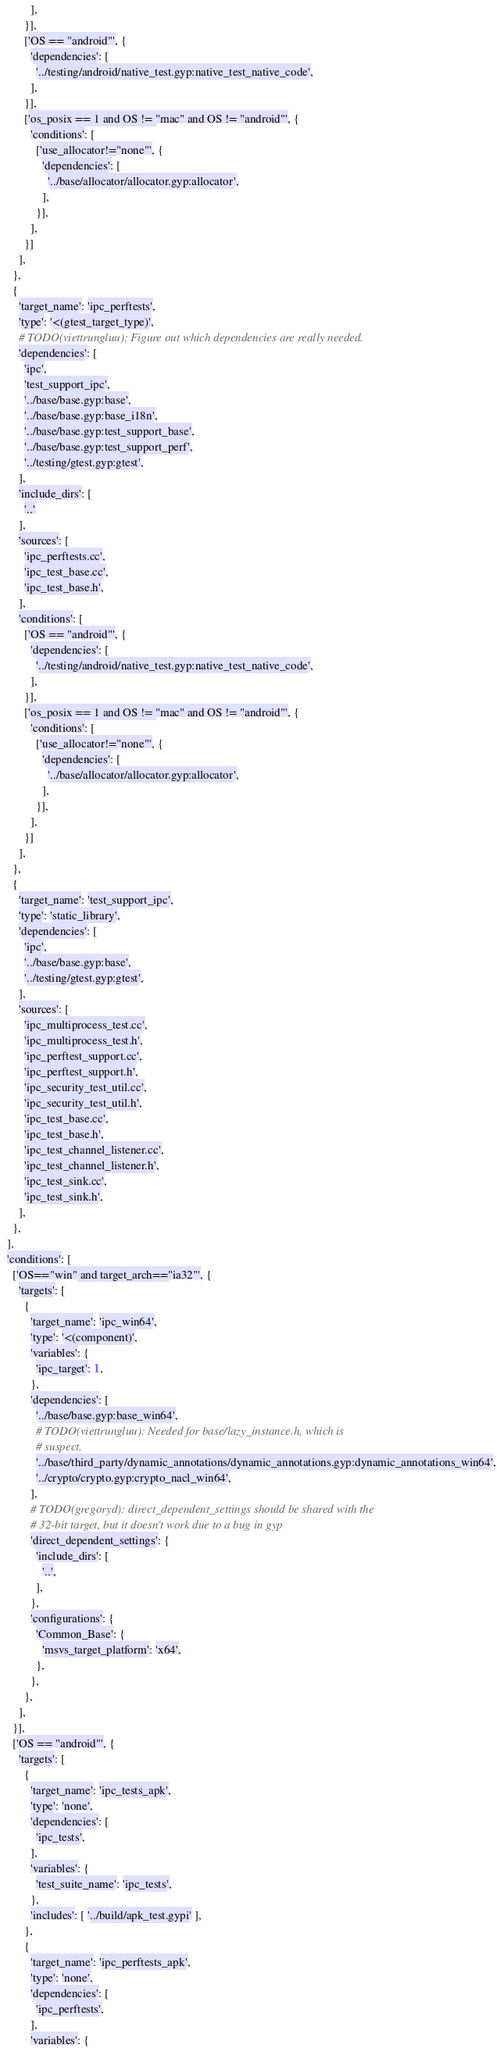Convert code to text. <code><loc_0><loc_0><loc_500><loc_500><_Python_>          ],
        }],
        ['OS == "android"', {
          'dependencies': [
            '../testing/android/native_test.gyp:native_test_native_code',
          ],
        }],
        ['os_posix == 1 and OS != "mac" and OS != "android"', {
          'conditions': [
            ['use_allocator!="none"', {
              'dependencies': [
                '../base/allocator/allocator.gyp:allocator',
              ],
            }],
          ],
        }]
      ],
    },
    {
      'target_name': 'ipc_perftests',
      'type': '<(gtest_target_type)',
      # TODO(viettrungluu): Figure out which dependencies are really needed.
      'dependencies': [
        'ipc',
        'test_support_ipc',
        '../base/base.gyp:base',
        '../base/base.gyp:base_i18n',
        '../base/base.gyp:test_support_base',
        '../base/base.gyp:test_support_perf',
        '../testing/gtest.gyp:gtest',
      ],
      'include_dirs': [
        '..'
      ],
      'sources': [
        'ipc_perftests.cc',
        'ipc_test_base.cc',
        'ipc_test_base.h',
      ],
      'conditions': [
        ['OS == "android"', {
          'dependencies': [
            '../testing/android/native_test.gyp:native_test_native_code',
          ],
        }],
        ['os_posix == 1 and OS != "mac" and OS != "android"', {
          'conditions': [
            ['use_allocator!="none"', {
              'dependencies': [
                '../base/allocator/allocator.gyp:allocator',
              ],
            }],
          ],
        }]
      ],
    },
    {
      'target_name': 'test_support_ipc',
      'type': 'static_library',
      'dependencies': [
        'ipc',
        '../base/base.gyp:base',
        '../testing/gtest.gyp:gtest',
      ],
      'sources': [
        'ipc_multiprocess_test.cc',
        'ipc_multiprocess_test.h',
        'ipc_perftest_support.cc',
        'ipc_perftest_support.h',
        'ipc_security_test_util.cc',
        'ipc_security_test_util.h',
        'ipc_test_base.cc',
        'ipc_test_base.h',
        'ipc_test_channel_listener.cc',
        'ipc_test_channel_listener.h',
        'ipc_test_sink.cc',
        'ipc_test_sink.h',
      ],
    },
  ],
  'conditions': [
    ['OS=="win" and target_arch=="ia32"', {
      'targets': [
        {
          'target_name': 'ipc_win64',
          'type': '<(component)',
          'variables': {
            'ipc_target': 1,
          },
          'dependencies': [
            '../base/base.gyp:base_win64',
            # TODO(viettrungluu): Needed for base/lazy_instance.h, which is
            # suspect.
            '../base/third_party/dynamic_annotations/dynamic_annotations.gyp:dynamic_annotations_win64',
            '../crypto/crypto.gyp:crypto_nacl_win64',
          ],
          # TODO(gregoryd): direct_dependent_settings should be shared with the
          # 32-bit target, but it doesn't work due to a bug in gyp
          'direct_dependent_settings': {
            'include_dirs': [
              '..',
            ],
          },
          'configurations': {
            'Common_Base': {
              'msvs_target_platform': 'x64',
            },
          },
        },
      ],
    }],
    ['OS == "android"', {
      'targets': [
        {
          'target_name': 'ipc_tests_apk',
          'type': 'none',
          'dependencies': [
            'ipc_tests',
          ],
          'variables': {
            'test_suite_name': 'ipc_tests',
          },
          'includes': [ '../build/apk_test.gypi' ],
        },
        {
          'target_name': 'ipc_perftests_apk',
          'type': 'none',
          'dependencies': [
            'ipc_perftests',
          ],
          'variables': {</code> 